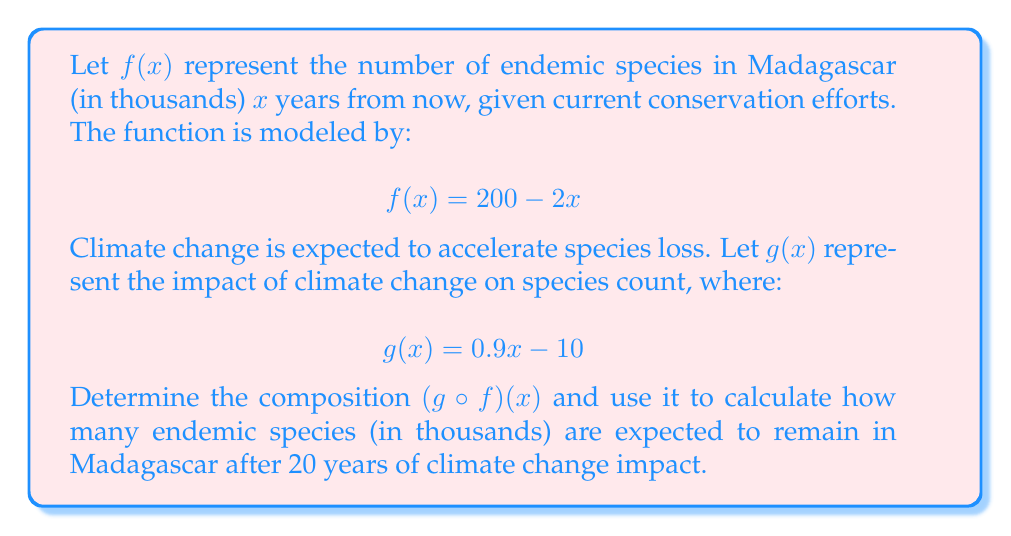Teach me how to tackle this problem. To solve this problem, we need to follow these steps:

1) First, we need to find the composition $(g \circ f)(x)$. This means we replace every $x$ in $g(x)$ with $f(x)$:

   $(g \circ f)(x) = g(f(x)) = 0.9(f(x)) - 10$

2) Now, we substitute the expression for $f(x)$:

   $(g \circ f)(x) = 0.9(200 - 2x) - 10$

3) Let's simplify this expression:
   
   $(g \circ f)(x) = 180 - 1.8x - 10 = 170 - 1.8x$

4) Now that we have the composition, we can use it to calculate the number of species after 20 years. We substitute $x = 20$ into our composed function:

   $(g \circ f)(20) = 170 - 1.8(20) = 170 - 36 = 134$

5) Therefore, after 20 years of climate change impact, there are expected to be 134 thousand endemic species remaining in Madagascar.
Answer: 134 thousand species 